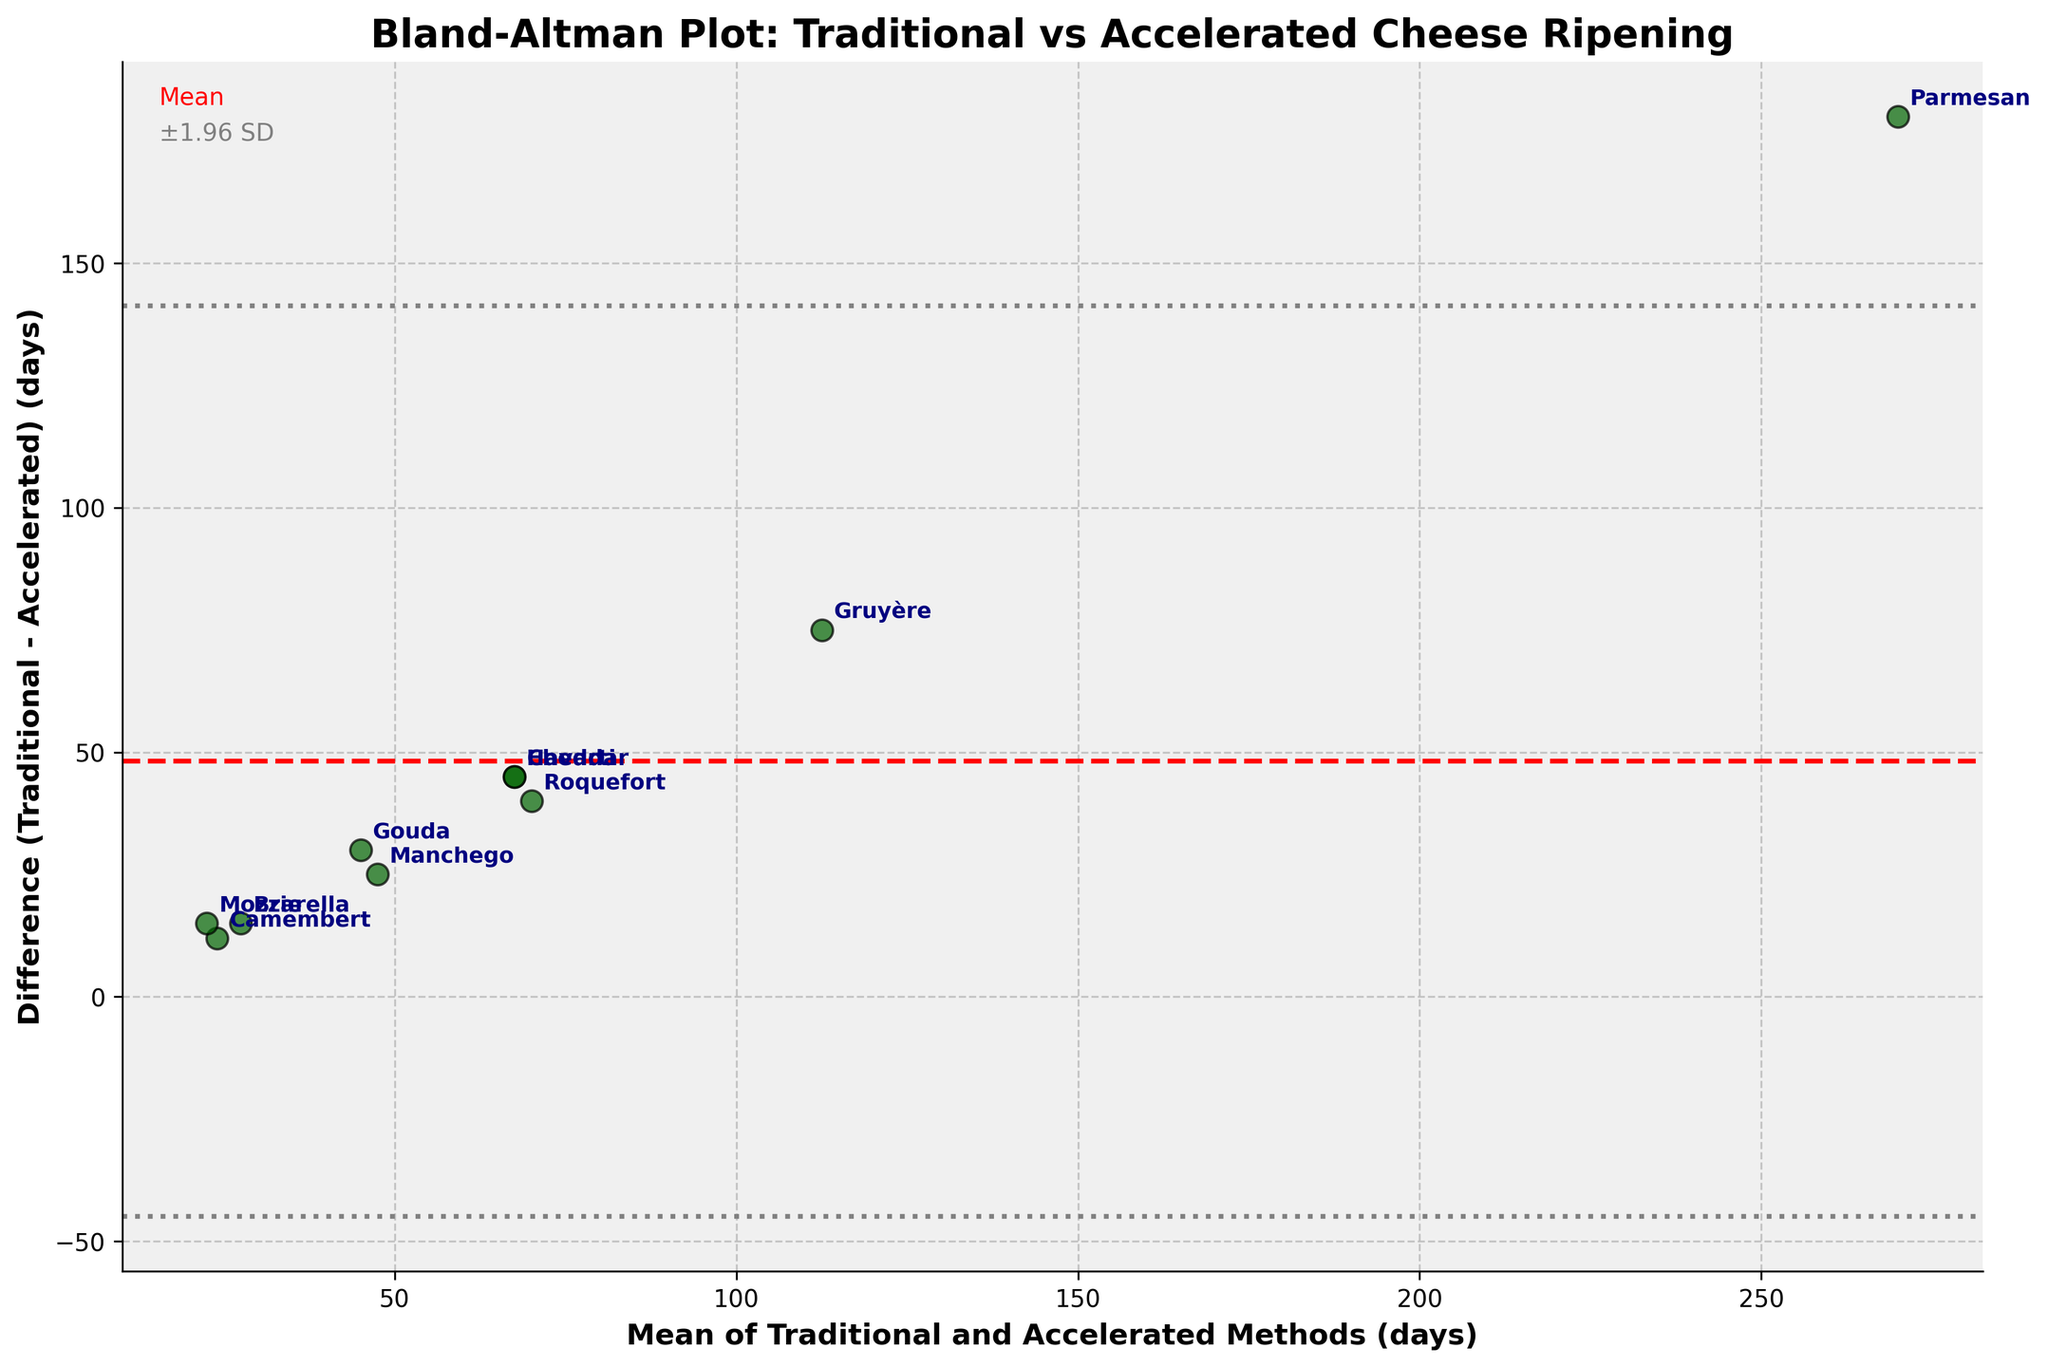What is the title of the plot? The title of the plot is usually displayed at the top of the figure. In this case, it reads 'Bland-Altman Plot: Traditional vs Accelerated Cheese Ripening'.
Answer: Bland-Altman Plot: Traditional vs Accelerated Cheese Ripening How many different types of cheese are represented in the plot? Each cheese type corresponds to a unique data point labeled on the plot. Counting these labels gives the total number. The plot labels 10 different cheeses.
Answer: 10 What does the red dashed line represent in the plot? In Bland-Altman plots, the red dashed line typically indicates the mean difference between the two methods. This line horizontally bisects the data points.
Answer: Mean difference Which cheese type shows the largest difference in ripening days between traditional and accelerated methods? By examining the vertical distance of each point from the mean difference line, Parmesan shows the largest difference as it's the highest point in terms of difference.
Answer: Parmesan Is the difference between traditional and accelerated ripening times generally positive or negative? The differences are mostly above the mean (positive values) with only a few below the line (negative values), indicating that traditional methods usually take longer than accelerated methods.
Answer: Positive What does the gray dotted line in the plot indicate? Gray dotted lines in Bland-Altman plots typically represent the limits of agreement, which are ±1.96 times the standard deviation from the mean difference.
Answer: ±1.96 SD Which cheese type falls closest to the mean difference line? Finding the point that lies nearest to the red dashed line, Havarti appears closest, indicating it has little variance between traditional and accelerated methods.
Answer: Havarti What is the difference in ripening days for Camembert cheese? By checking the plot, the Camembert cheese point has a vertical value (difference) of 12 which is found near 24 on the combined average axis.
Answer: 12 days Are any cheese types outside the limits of agreement? By observing which data points lie outside the gray dotted lines, no cheese types are outside these vertical boundaries, indicating all data points fall within the specified limits of agreement.
Answer: No At what average ripening time do most of the data points cluster? The clustering of data points occurs noticeably around the average of 45-70 days for combined averages as this is where most points are densely packed.
Answer: Around 45-70 days 